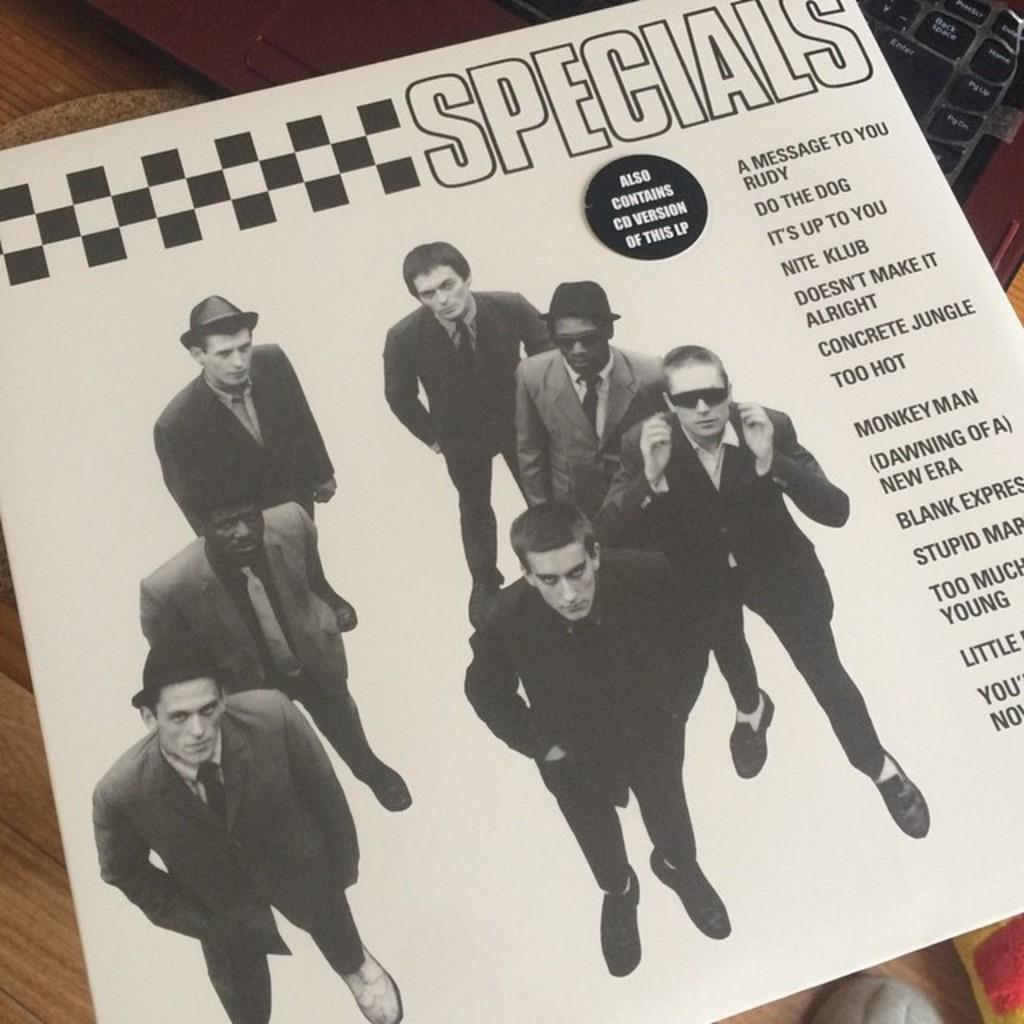What is present on the paper in the image? People and text are printed on the paper. Where is the paper located in the image? The paper is placed on a keyboard. What type of soap is visible on the paper in the image? There is no soap present on the paper in the image. How many fangs can be seen on the people printed on the paper? There are no fangs depicted on the people printed on the paper in the image. 